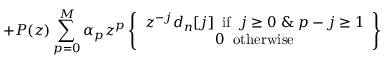Convert formula to latex. <formula><loc_0><loc_0><loc_500><loc_500>+ P ( z ) \sum _ { p = 0 } ^ { M } \alpha _ { p } z ^ { p } \left \{ \begin{array} { c } { z ^ { - j } d _ { n } [ j ] \, i f \, j \geq 0 \, \& \, p - j \geq 1 } \\ { 0 \, o t h e r w i s e } \end{array} \right \}</formula> 